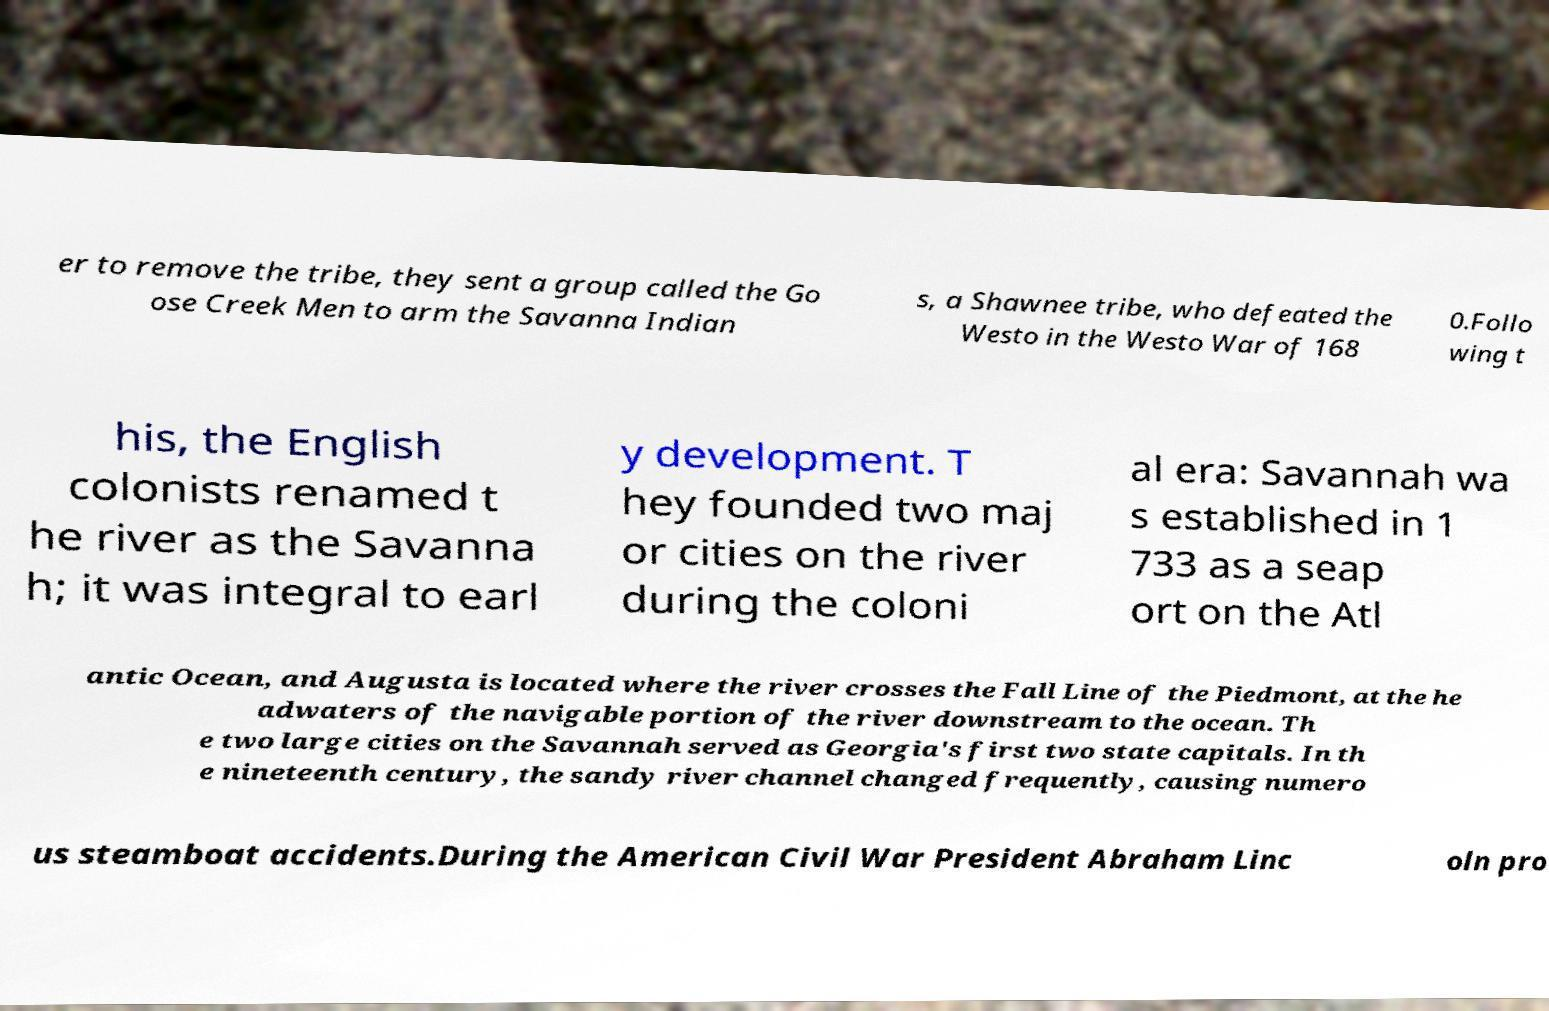There's text embedded in this image that I need extracted. Can you transcribe it verbatim? er to remove the tribe, they sent a group called the Go ose Creek Men to arm the Savanna Indian s, a Shawnee tribe, who defeated the Westo in the Westo War of 168 0.Follo wing t his, the English colonists renamed t he river as the Savanna h; it was integral to earl y development. T hey founded two maj or cities on the river during the coloni al era: Savannah wa s established in 1 733 as a seap ort on the Atl antic Ocean, and Augusta is located where the river crosses the Fall Line of the Piedmont, at the he adwaters of the navigable portion of the river downstream to the ocean. Th e two large cities on the Savannah served as Georgia's first two state capitals. In th e nineteenth century, the sandy river channel changed frequently, causing numero us steamboat accidents.During the American Civil War President Abraham Linc oln pro 